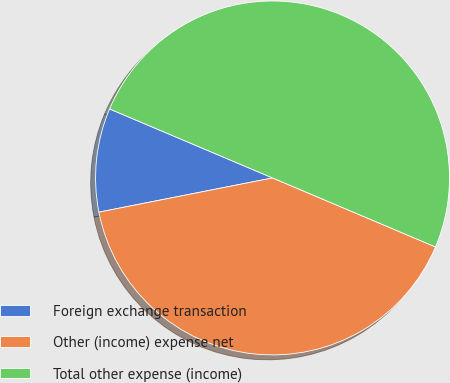Convert chart to OTSL. <chart><loc_0><loc_0><loc_500><loc_500><pie_chart><fcel>Foreign exchange transaction<fcel>Other (income) expense net<fcel>Total other expense (income)<nl><fcel>9.47%<fcel>40.53%<fcel>50.0%<nl></chart> 